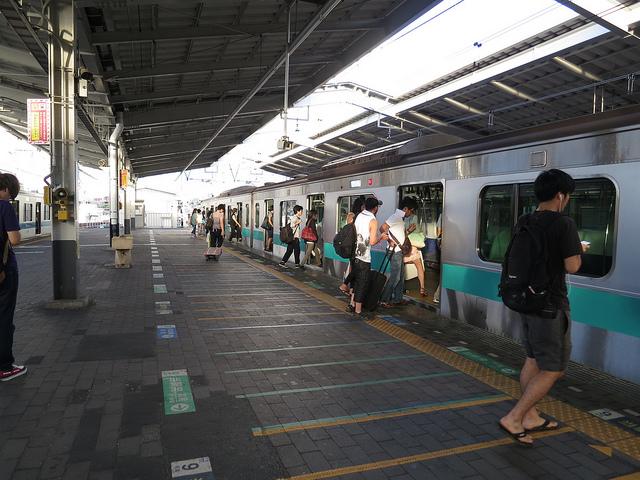Is anyone getting on the train?
Give a very brief answer. Yes. Should people try to get off the train right now?
Answer briefly. Yes. Is the train starting or stopping?
Answer briefly. Stopping. How many people are getting on the train?
Give a very brief answer. 8. Is the train moving very fast?
Write a very short answer. No. How many people are there?
Write a very short answer. 12. What is the train stopped next to?
Quick response, please. Platform. Is the man walking?
Keep it brief. Yes. Yes they are?
Short answer required. Yes. 